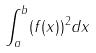<formula> <loc_0><loc_0><loc_500><loc_500>\int _ { a } ^ { b } ( f ( x ) ) ^ { 2 } d x</formula> 